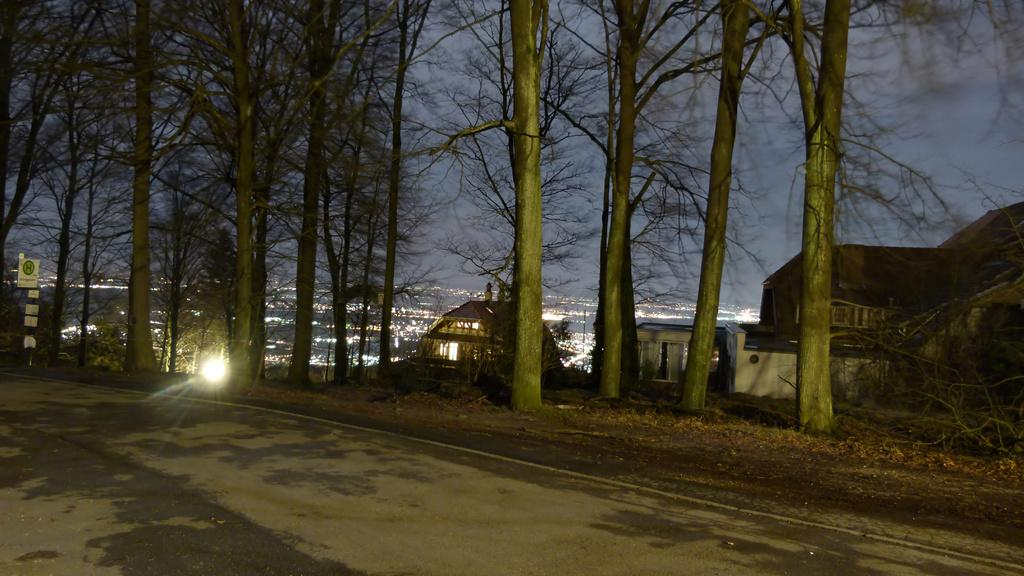What is located at the bottom of the image? There is a road at the bottom of the image. What can be seen in the background of the image? There are trees and sheds in the background of the image. What is present on the left side of the image? There is a sign board on the left side of the image. What part of the natural environment is visible in the image? The sky is visible in the background of the image. How many family members are visible in the image? There are no family members present in the image. What is the size of the sheds in the image? The size of the sheds cannot be determined from the image alone. 